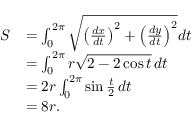<formula> <loc_0><loc_0><loc_500><loc_500>{ \begin{array} { r l } { S } & { = \int _ { 0 } ^ { 2 \pi } { \sqrt { \left ( { \frac { d x } { d t } } \right ) ^ { 2 } + \left ( { \frac { d y } { d t } } \right ) ^ { 2 } } } d t } \\ & { = \int _ { 0 } ^ { 2 \pi } r { \sqrt { 2 - 2 \cos t } } \, d t } \\ & { = 2 r \int _ { 0 } ^ { 2 \pi } \sin { \frac { t } { 2 } } \, d t } \\ & { = 8 r . } \end{array} }</formula> 